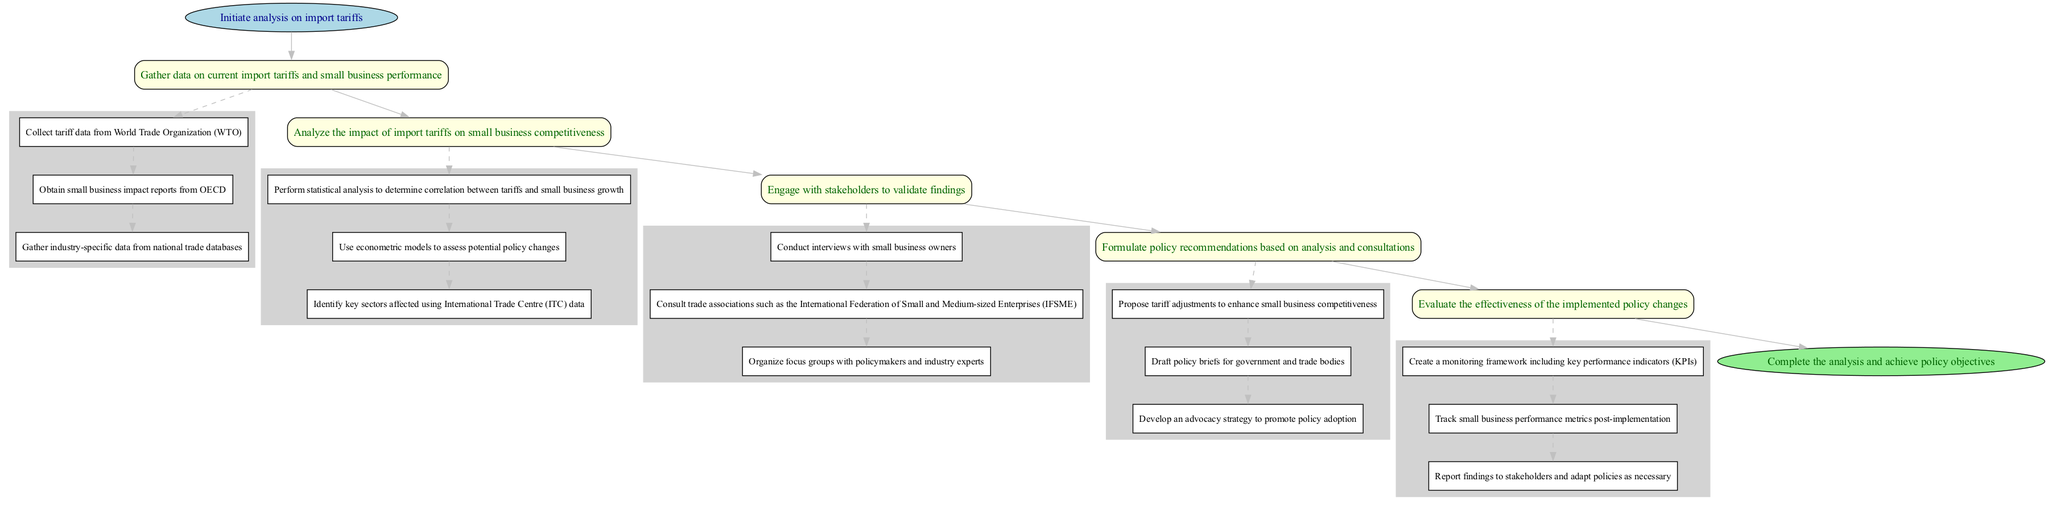What is the first step in the analysis? The diagram indicates that the first step is "Gather data on current import tariffs and small business performance" which is listed under the first main step.
Answer: Gather data on current import tariffs and small business performance How many main steps are present in the diagram? By counting the main steps within the diagram, we find there are five distinct steps leading from start to end.
Answer: 5 What type of data is collected in the data collection step? The substeps under the data collection step specify that the data includes tariff data from WTO, small business impact reports from OECD, and industry-specific data from national trade databases.
Answer: Tariff data from WTO, small business impact reports from OECD, and industry-specific data Which step follows stakeholder consultation? The flow of the diagram shows that after the "Engage with stakeholders to validate findings" step, the next step is "Formulate policy recommendations based on analysis and consultations."
Answer: Formulate policy recommendations based on analysis and consultations What is the main objective of the evaluation step? The evaluation step aims to assess how effective the implemented policy changes have been, as indicated by the description of this step.
Answer: Evaluate the effectiveness of the implemented policy changes What is one method used in the data analysis step? The substeps in the data analysis step explicitly mention performing statistical analysis to determine correlation between tariffs and small business growth.
Answer: Statistical analysis What connects the data analysis step and the stakeholder consultation step? The connection between these two steps is depicted by an edge that shows the flow from the analysis stage directly into consulting with stakeholders, indicating an iterative process.
Answer: Stakeholder consultation How many substeps are included in the recommendations step? Upon reviewing the recommendations step, there are three specific substeps mentioned, indicating the detailed actions to be taken.
Answer: 3 What is the final goal of the entire analysis process? The diagram concludes with the goal of "Complete the analysis and achieve policy objectives," making it clear that the ultimate aim is to complete the analysis successfully.
Answer: Complete the analysis and achieve policy objectives 